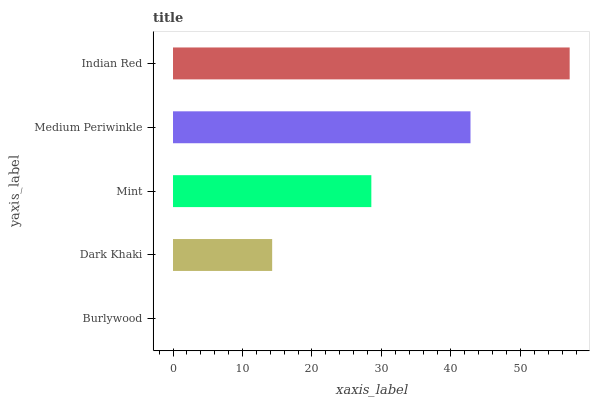Is Burlywood the minimum?
Answer yes or no. Yes. Is Indian Red the maximum?
Answer yes or no. Yes. Is Dark Khaki the minimum?
Answer yes or no. No. Is Dark Khaki the maximum?
Answer yes or no. No. Is Dark Khaki greater than Burlywood?
Answer yes or no. Yes. Is Burlywood less than Dark Khaki?
Answer yes or no. Yes. Is Burlywood greater than Dark Khaki?
Answer yes or no. No. Is Dark Khaki less than Burlywood?
Answer yes or no. No. Is Mint the high median?
Answer yes or no. Yes. Is Mint the low median?
Answer yes or no. Yes. Is Medium Periwinkle the high median?
Answer yes or no. No. Is Dark Khaki the low median?
Answer yes or no. No. 